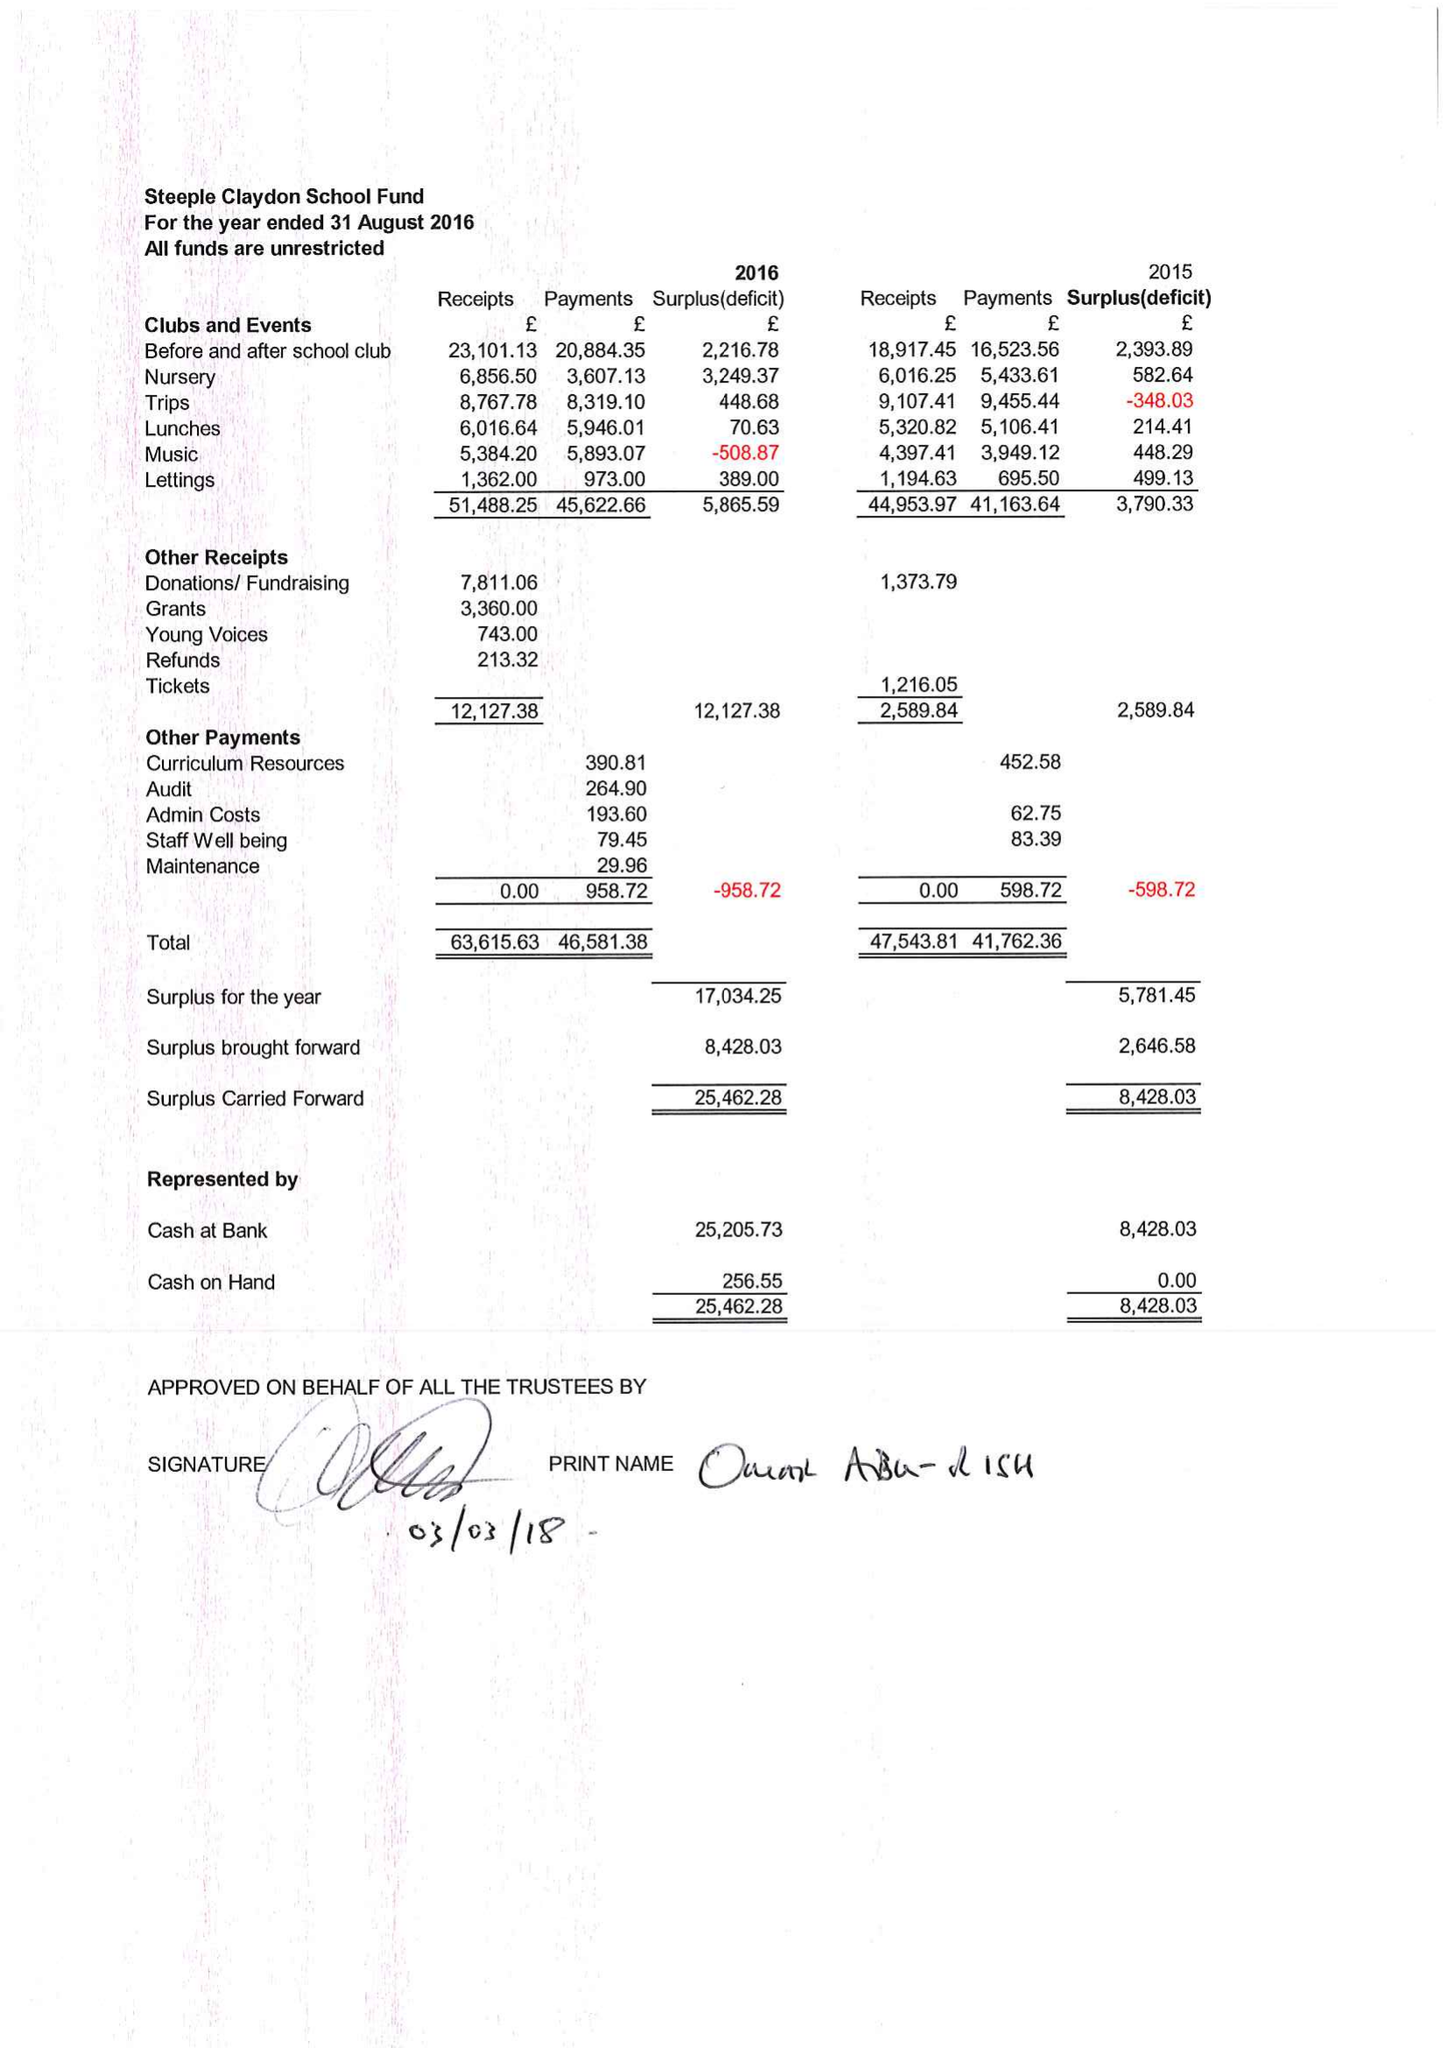What is the value for the charity_number?
Answer the question using a single word or phrase. 1064577 